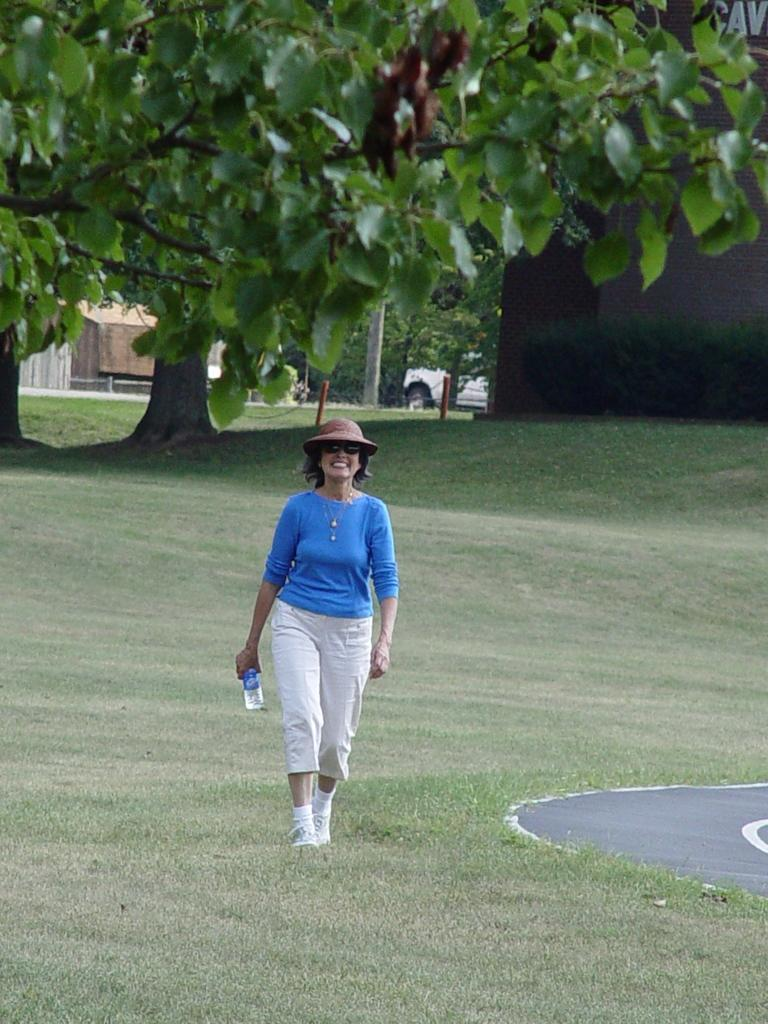Who is present in the image? There is a woman in the image. What is the woman doing in the image? The woman is standing on the ground and smiling. What is the woman wearing in the image? The woman is wearing spectacles. What is the woman holding in the image? The woman is holding a bottle. What can be seen in the background of the image? There are trees and a vehicle in the background of the image. What type of operation is the woman performing on the person in the image? There is no person present in the image, and the woman is not performing any operation. 